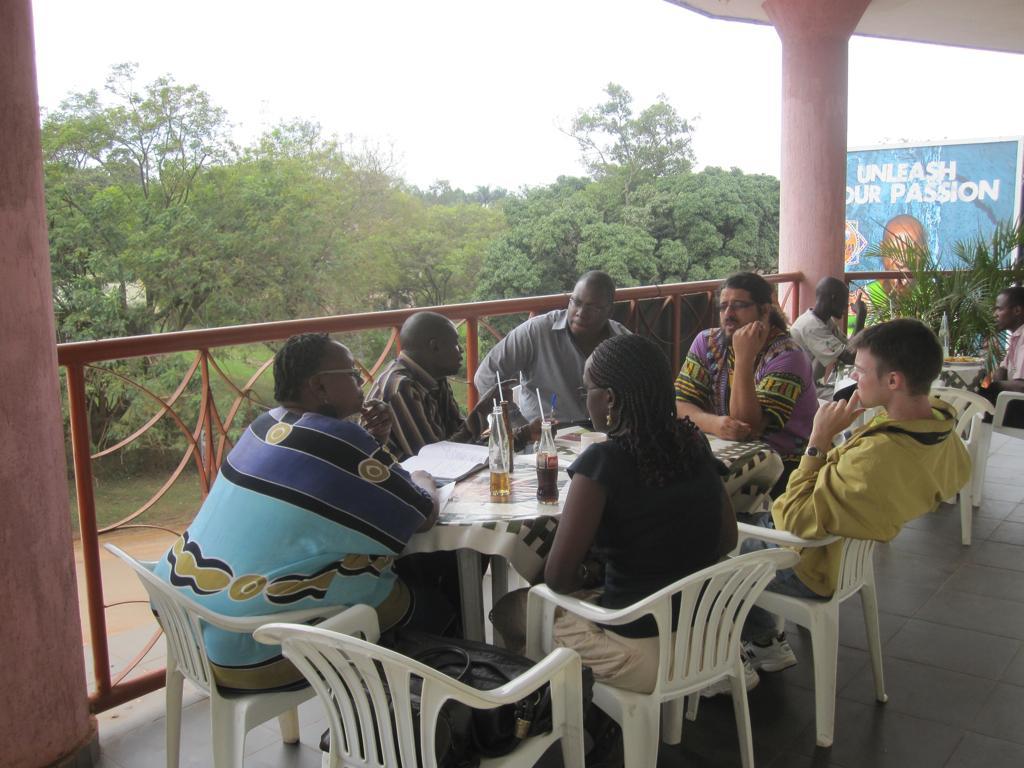How would you summarize this image in a sentence or two? In this image, we can see people sitting on the chairs and there are drinks, papers and some other objects on the tables. In the background, there are trees, railings, plants, pillars and there is a banner with some text and a picture of a person. At the bottom, there is a floor and at the top, there is sky. 